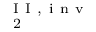<formula> <loc_0><loc_0><loc_500><loc_500>_ { 2 } ^ { I I , i n v }</formula> 